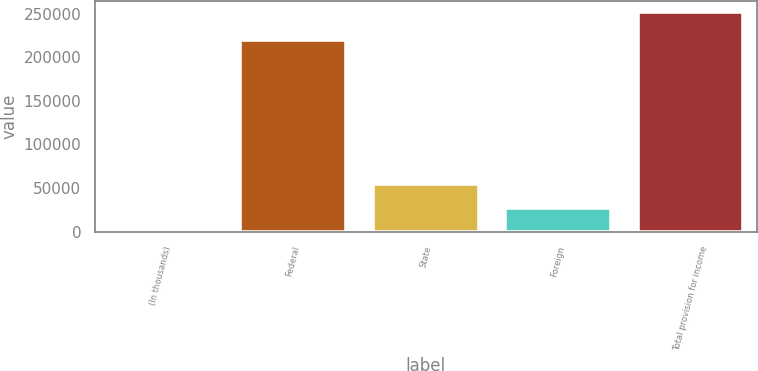<chart> <loc_0><loc_0><loc_500><loc_500><bar_chart><fcel>(In thousands)<fcel>Federal<fcel>State<fcel>Foreign<fcel>Total provision for income<nl><fcel>2007<fcel>220064<fcel>54372<fcel>26967<fcel>251607<nl></chart> 